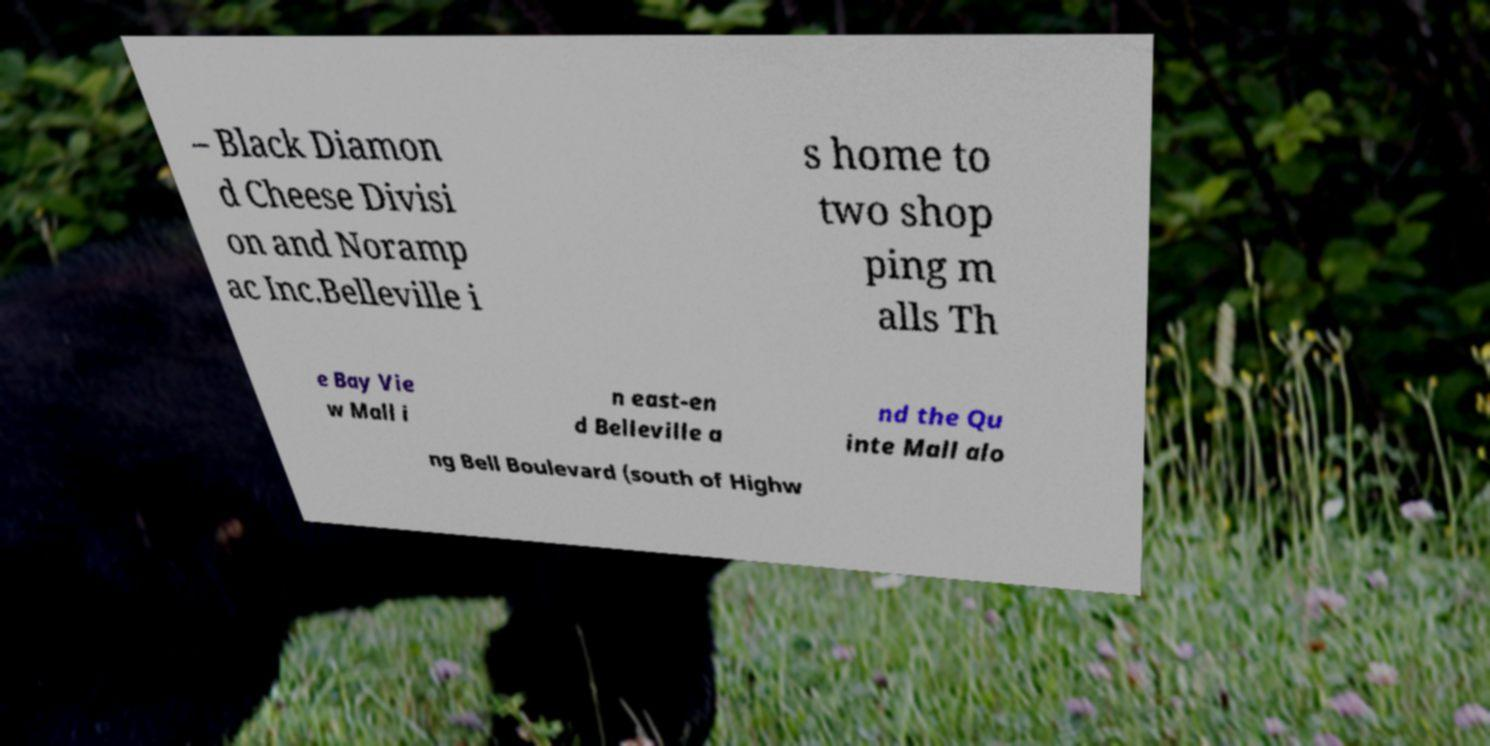Could you assist in decoding the text presented in this image and type it out clearly? – Black Diamon d Cheese Divisi on and Noramp ac Inc.Belleville i s home to two shop ping m alls Th e Bay Vie w Mall i n east-en d Belleville a nd the Qu inte Mall alo ng Bell Boulevard (south of Highw 